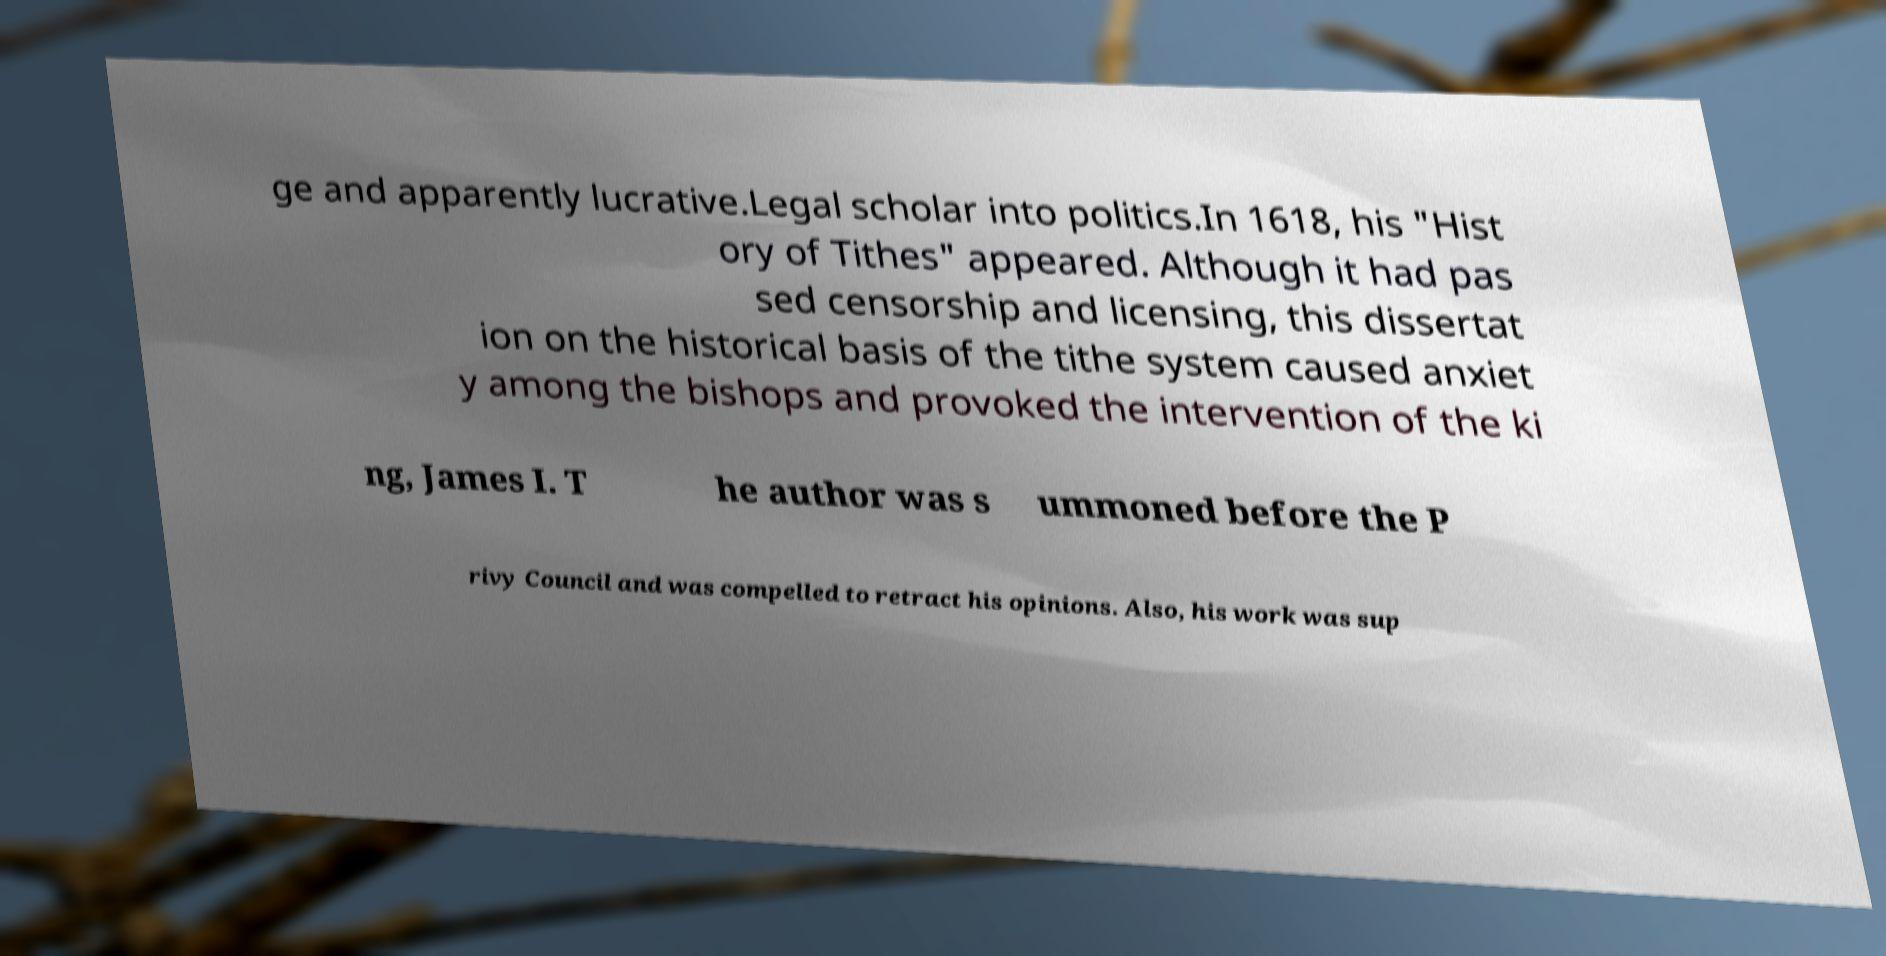Can you accurately transcribe the text from the provided image for me? ge and apparently lucrative.Legal scholar into politics.In 1618, his "Hist ory of Tithes" appeared. Although it had pas sed censorship and licensing, this dissertat ion on the historical basis of the tithe system caused anxiet y among the bishops and provoked the intervention of the ki ng, James I. T he author was s ummoned before the P rivy Council and was compelled to retract his opinions. Also, his work was sup 